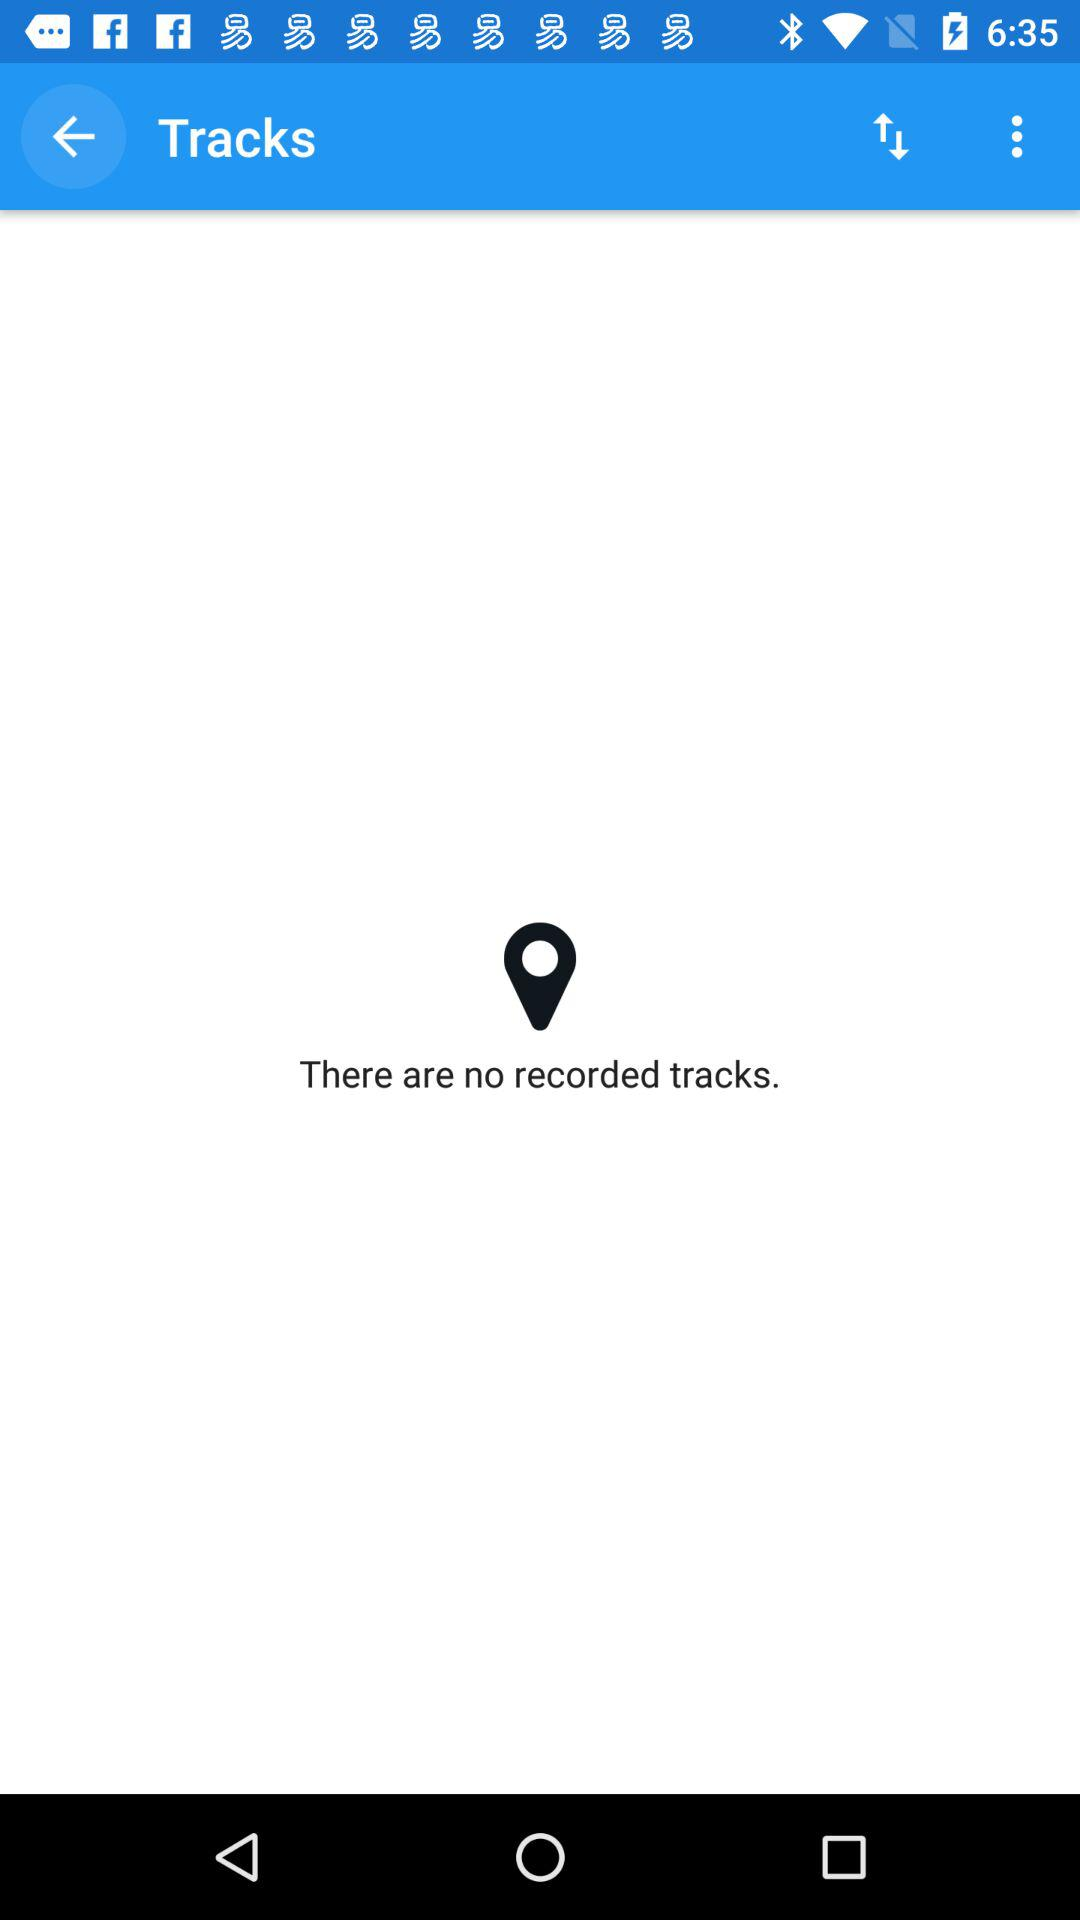Are there any recorded tracks? There are no recorded tracks. 